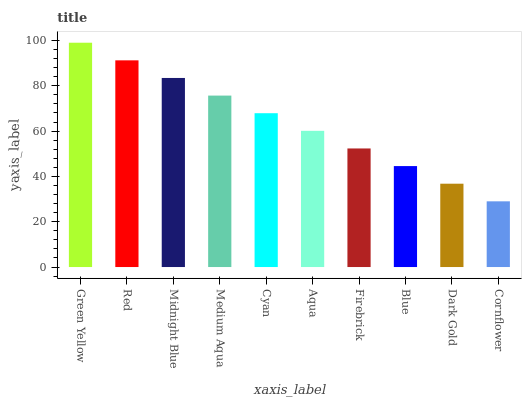Is Cornflower the minimum?
Answer yes or no. Yes. Is Green Yellow the maximum?
Answer yes or no. Yes. Is Red the minimum?
Answer yes or no. No. Is Red the maximum?
Answer yes or no. No. Is Green Yellow greater than Red?
Answer yes or no. Yes. Is Red less than Green Yellow?
Answer yes or no. Yes. Is Red greater than Green Yellow?
Answer yes or no. No. Is Green Yellow less than Red?
Answer yes or no. No. Is Cyan the high median?
Answer yes or no. Yes. Is Aqua the low median?
Answer yes or no. Yes. Is Firebrick the high median?
Answer yes or no. No. Is Firebrick the low median?
Answer yes or no. No. 